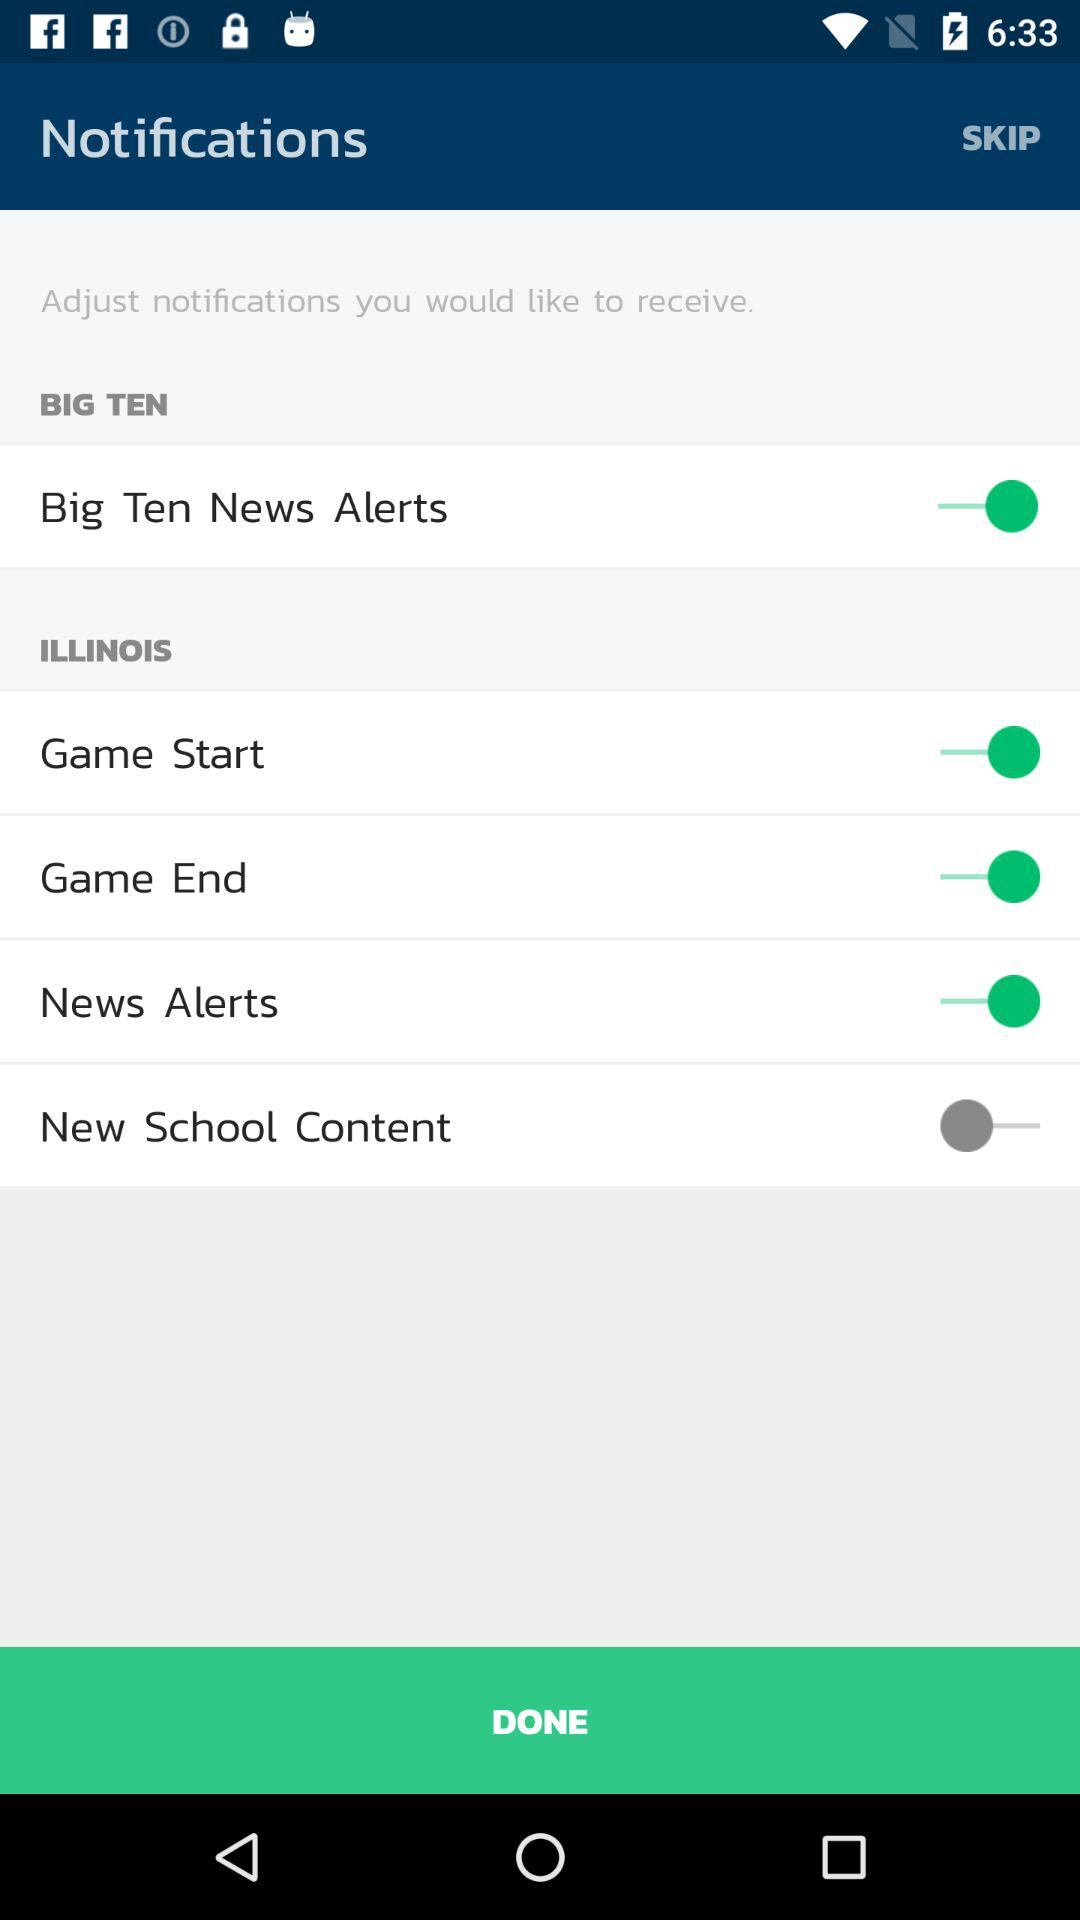What is the status of the "News Alerts"? The status of the "News Alerts" is "on". 